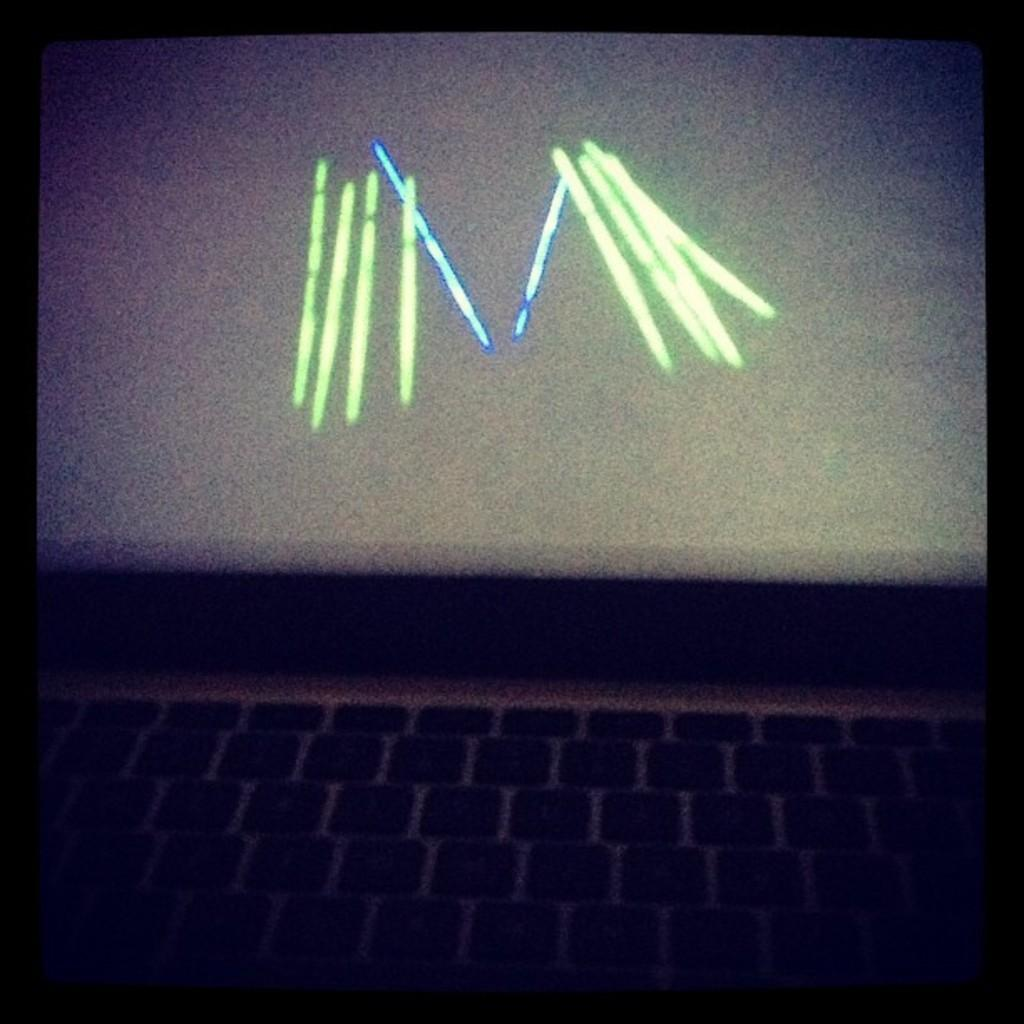What electronic device is visible in the image? There is a laptop in the image. What is the state of the laptop in the image? The laptop is opened. What can be seen on the laptop screen? There are green and blue colored lines on the laptop screen. How many cows are grazing near the laptop in the image? There are no cows present in the image; it only features a laptop with colored lines on the screen. 